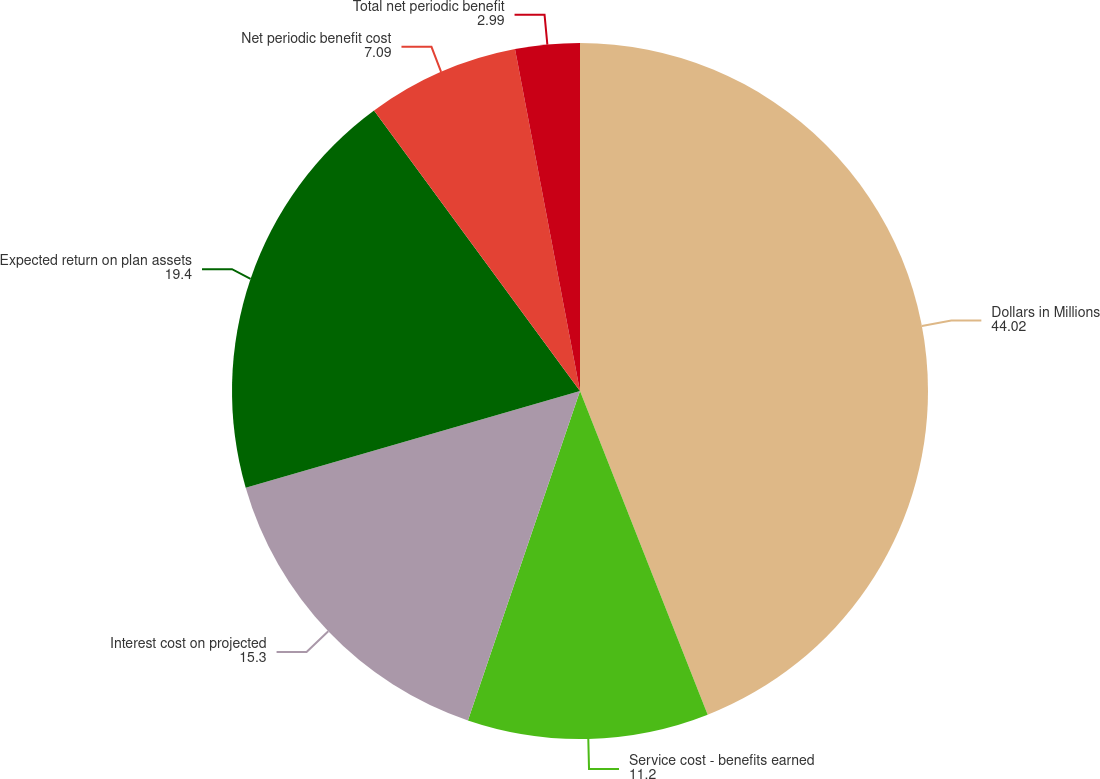Convert chart. <chart><loc_0><loc_0><loc_500><loc_500><pie_chart><fcel>Dollars in Millions<fcel>Service cost - benefits earned<fcel>Interest cost on projected<fcel>Expected return on plan assets<fcel>Net periodic benefit cost<fcel>Total net periodic benefit<nl><fcel>44.02%<fcel>11.2%<fcel>15.3%<fcel>19.4%<fcel>7.09%<fcel>2.99%<nl></chart> 